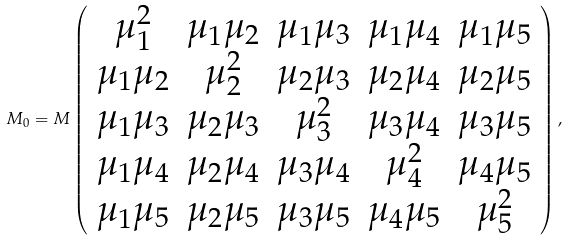<formula> <loc_0><loc_0><loc_500><loc_500>M _ { 0 } = M \left ( \begin{array} { c c c c c } \mu _ { 1 } ^ { 2 } & \mu _ { 1 } \mu _ { 2 } & \mu _ { 1 } \mu _ { 3 } & \mu _ { 1 } \mu _ { 4 } & \mu _ { 1 } \mu _ { 5 } \\ \mu _ { 1 } \mu _ { 2 } & \mu _ { 2 } ^ { 2 } & \mu _ { 2 } \mu _ { 3 } & \mu _ { 2 } \mu _ { 4 } & \mu _ { 2 } \mu _ { 5 } \\ \mu _ { 1 } \mu _ { 3 } & \mu _ { 2 } \mu _ { 3 } & \mu _ { 3 } ^ { 2 } & \mu _ { 3 } \mu _ { 4 } & \mu _ { 3 } \mu _ { 5 } \\ \mu _ { 1 } \mu _ { 4 } & \mu _ { 2 } \mu _ { 4 } & \mu _ { 3 } \mu _ { 4 } & \mu _ { 4 } ^ { 2 } & \mu _ { 4 } \mu _ { 5 } \\ \mu _ { 1 } \mu _ { 5 } & \mu _ { 2 } \mu _ { 5 } & \mu _ { 3 } \mu _ { 5 } & \mu _ { 4 } \mu _ { 5 } & \mu _ { 5 } ^ { 2 } \\ \end{array} \right ) ,</formula> 